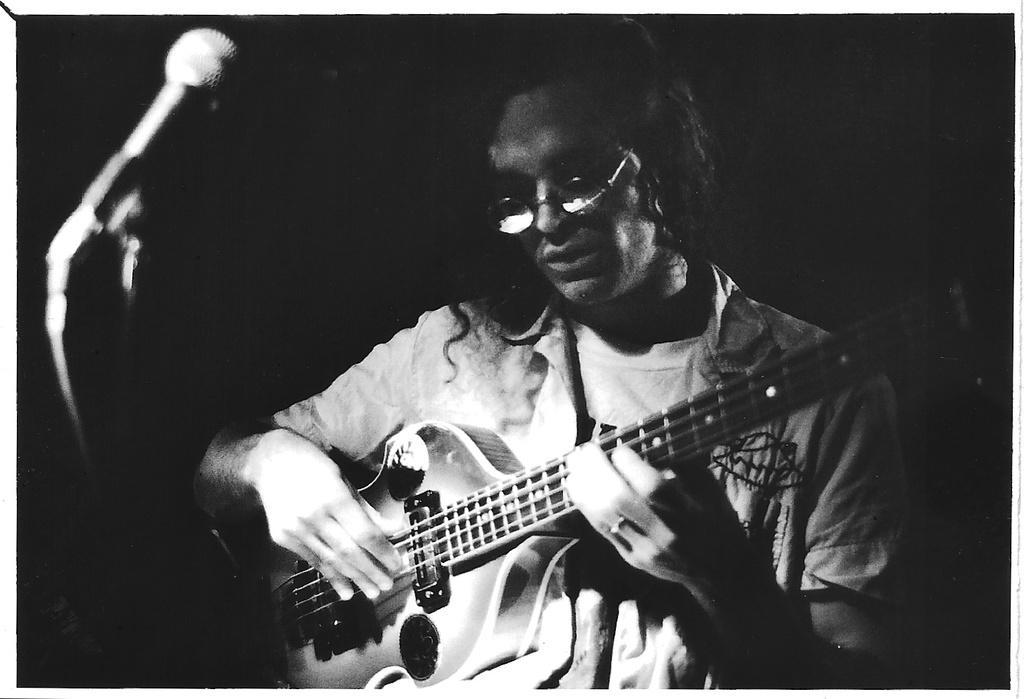Describe this image in one or two sentences. A black and white picture. This man wore spectacles and playing guitar in-front of mic. 